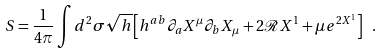<formula> <loc_0><loc_0><loc_500><loc_500>S = \frac { 1 } { 4 \pi } \int d ^ { 2 } \sigma \sqrt { h } \left [ h ^ { a b } \partial _ { a } X ^ { \mu } \partial _ { b } X _ { \mu } + 2 \mathcal { R } X ^ { 1 } + \mu e ^ { 2 X ^ { 1 } } \right ] \ .</formula> 